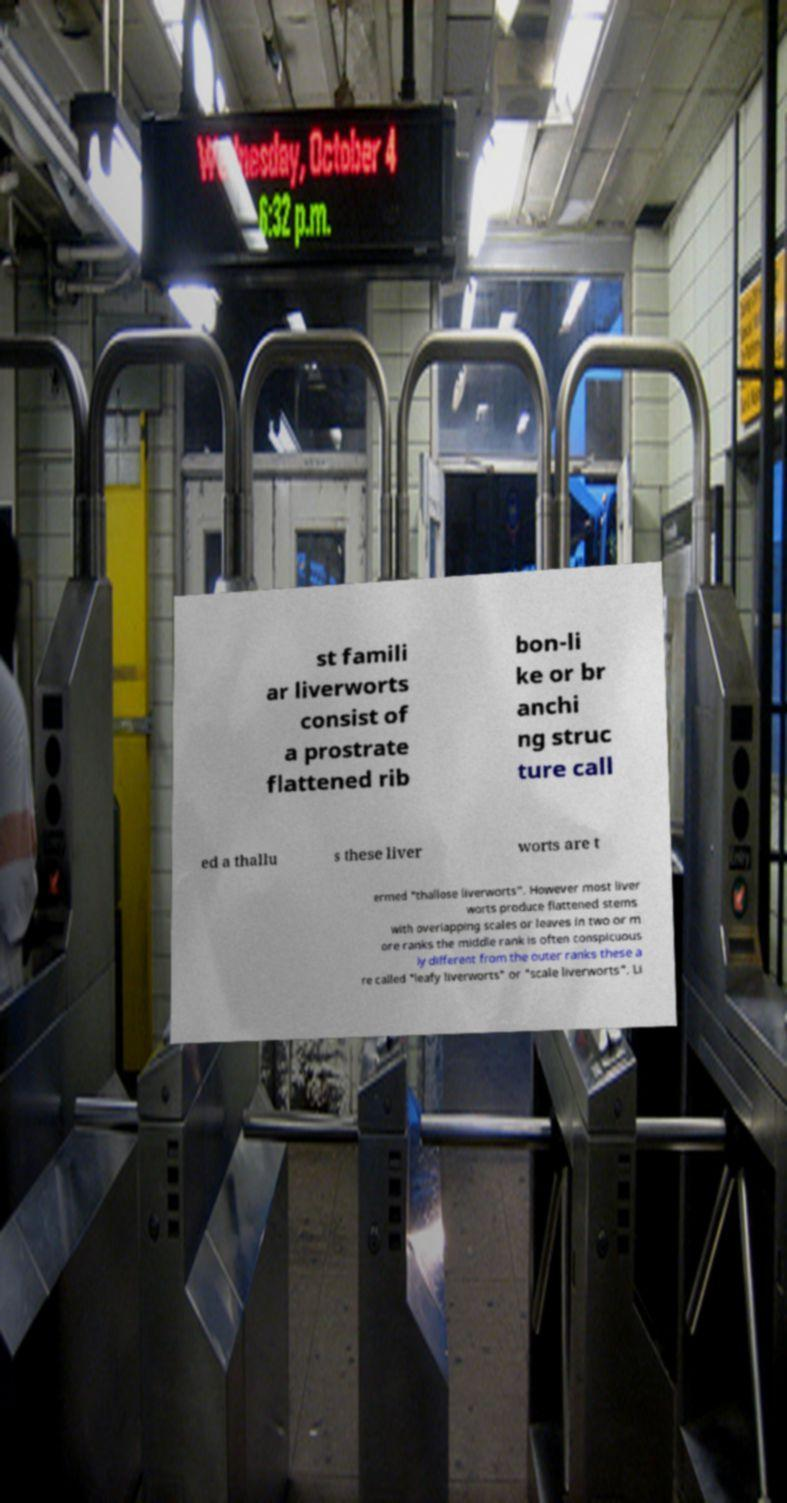What messages or text are displayed in this image? I need them in a readable, typed format. st famili ar liverworts consist of a prostrate flattened rib bon-li ke or br anchi ng struc ture call ed a thallu s these liver worts are t ermed "thallose liverworts". However most liver worts produce flattened stems with overlapping scales or leaves in two or m ore ranks the middle rank is often conspicuous ly different from the outer ranks these a re called "leafy liverworts" or "scale liverworts". Li 